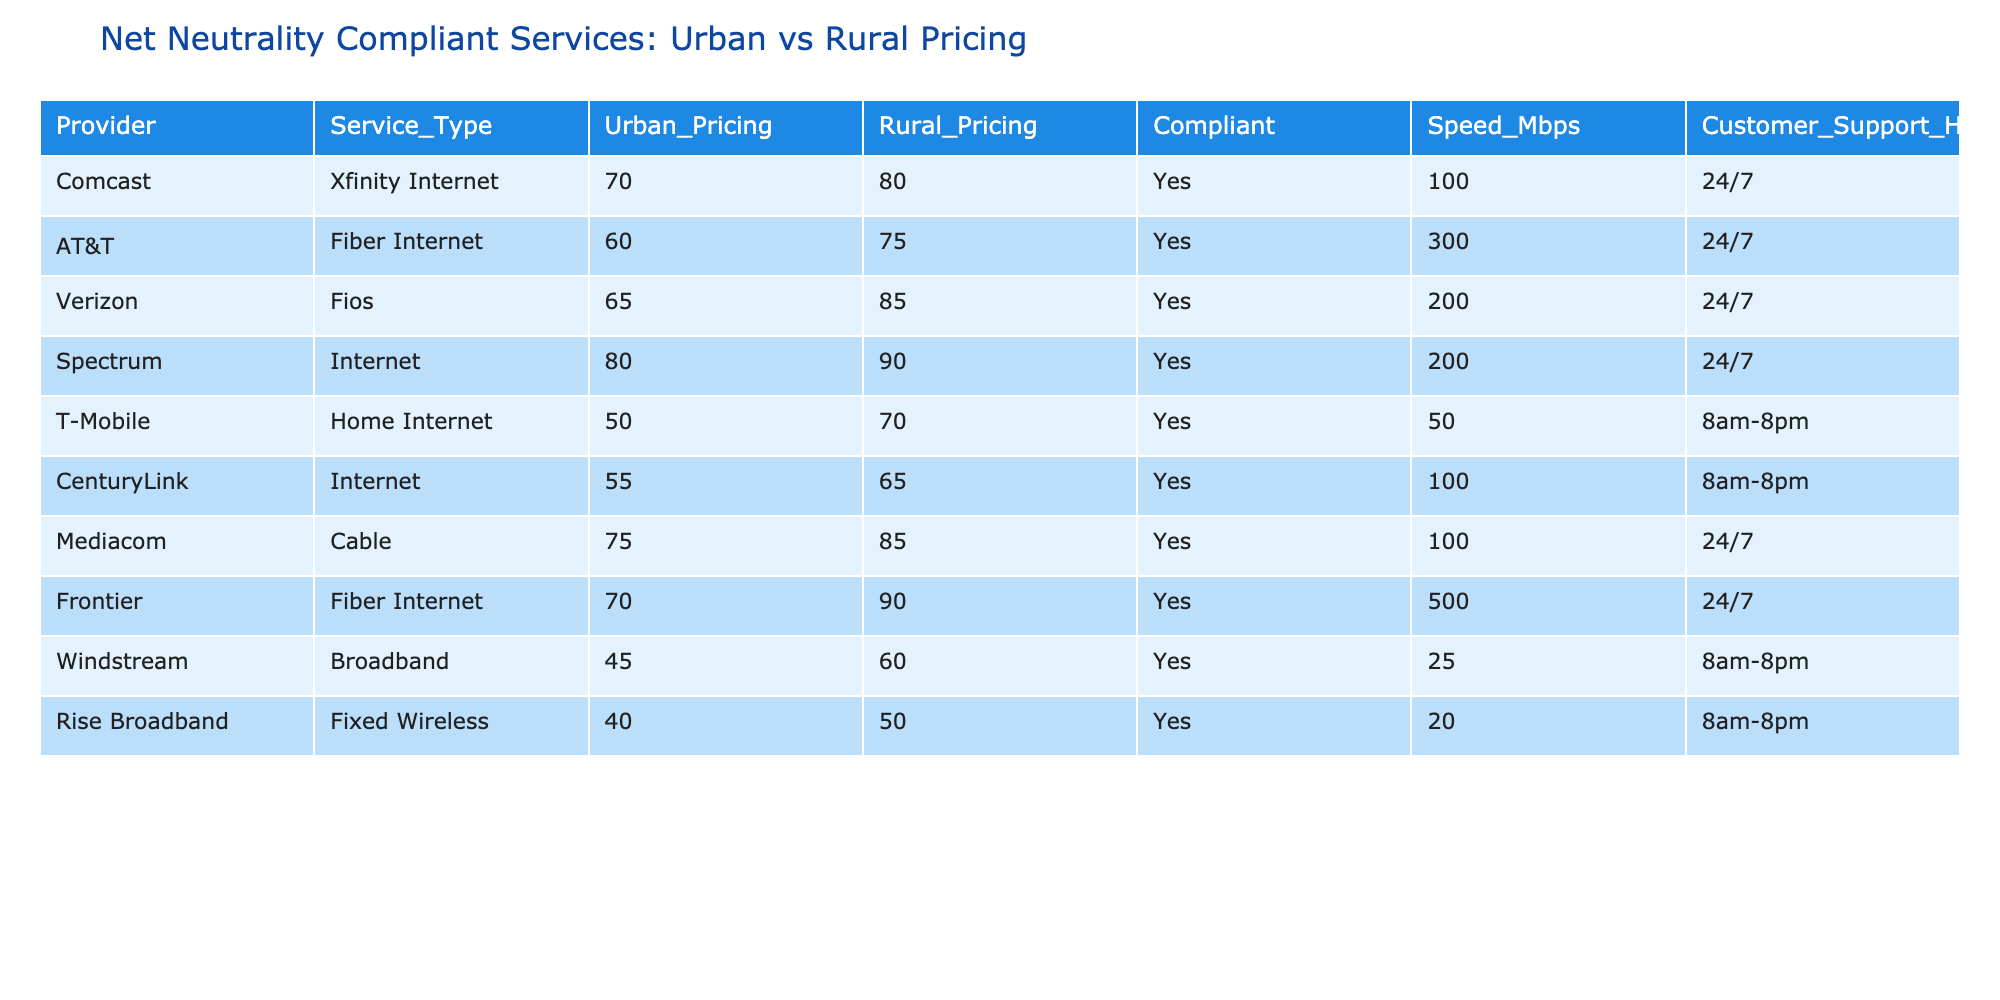What is the price of Comcast's Xfinity Internet service in urban areas? The table shows the Urban Pricing column for Comcast's Xfinity Internet service as 70.
Answer: 70 Which provider offers the fastest speed in rural areas, and what is that speed? When looking under Rural Pricing, Frontier's Fiber Internet provides the highest speed at 500 Mbps.
Answer: 500 Mbps Is T-Mobile's Home Internet service compliant with net neutrality? The table indicates that T-Mobile's service is marked as "Yes" in the Compliant column.
Answer: Yes What is the price difference between Spectrum's urban and rural pricing? Spectrum's urban pricing is 80, while rural pricing is 90. Thus, the price difference is calculated as 90 - 80 = 10.
Answer: 10 Which service type has the lowest urban pricing, and what is its price? By comparing the Urban Pricing column, Windstream's Broadband service has the lowest price at 45.
Answer: 45 How many providers offer customer support 24/7? Looking through the Customer Support Hours column, 5 providers (Comcast, AT&T, Verizon, Spectrum, Mediacom, and Frontier) have 24/7 support.
Answer: 6 What is the average urban pricing of all compliant services available? Adding up the urban pricing values: (70 + 60 + 65 + 80 + 50 + 55 + 75 + 70 + 45 + 40) gives a total of 665. Since there are 10 services, the average is 665 / 10 = 66.5.
Answer: 66.5 Which provider has the highest rural pricing, and what is that price? By examining the Rural Pricing column, Spectrum shows the highest price at 90.
Answer: 90 Is there a provider that has a higher speed in urban areas than in rural areas? Comparing speeds, Frontier has 500 Mbps in urban areas and 500 Mbps in rural areas, while T-Mobile has lower speeds in urban (50) vs rural (70). So there is no provider with higher speed in urban areas.
Answer: No 